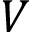Convert formula to latex. <formula><loc_0><loc_0><loc_500><loc_500>V</formula> 